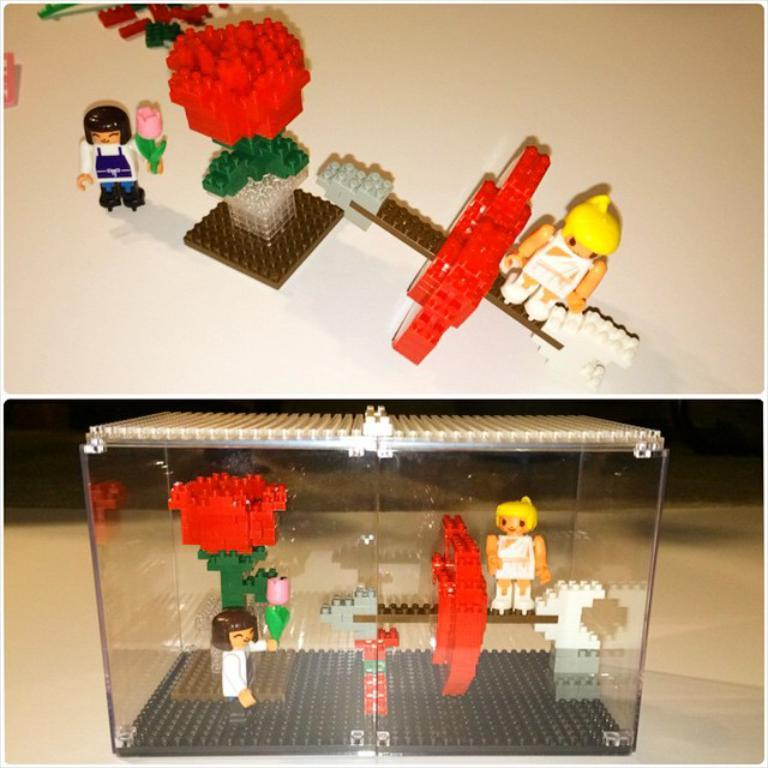What type of toys are in the image? There are Lego toys in the image. Where are some of the toys located? Some toys are placed in a glass box on the floor, and there are toys on a platform at the top of the image. How do the toys support the swing in the image? There is no swing present in the image; the toys are either in a glass box on the floor or on a platform at the top of the image. 